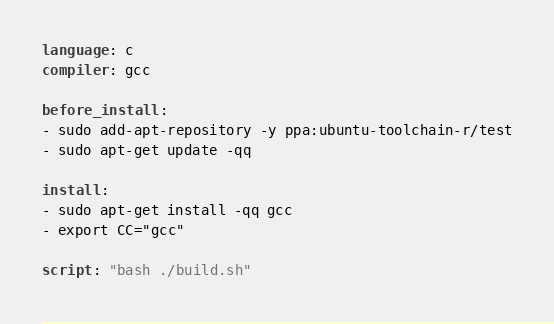Convert code to text. <code><loc_0><loc_0><loc_500><loc_500><_YAML_>language: c
compiler: gcc

before_install:
- sudo add-apt-repository -y ppa:ubuntu-toolchain-r/test
- sudo apt-get update -qq

install:
- sudo apt-get install -qq gcc
- export CC="gcc"

script: "bash ./build.sh"</code> 